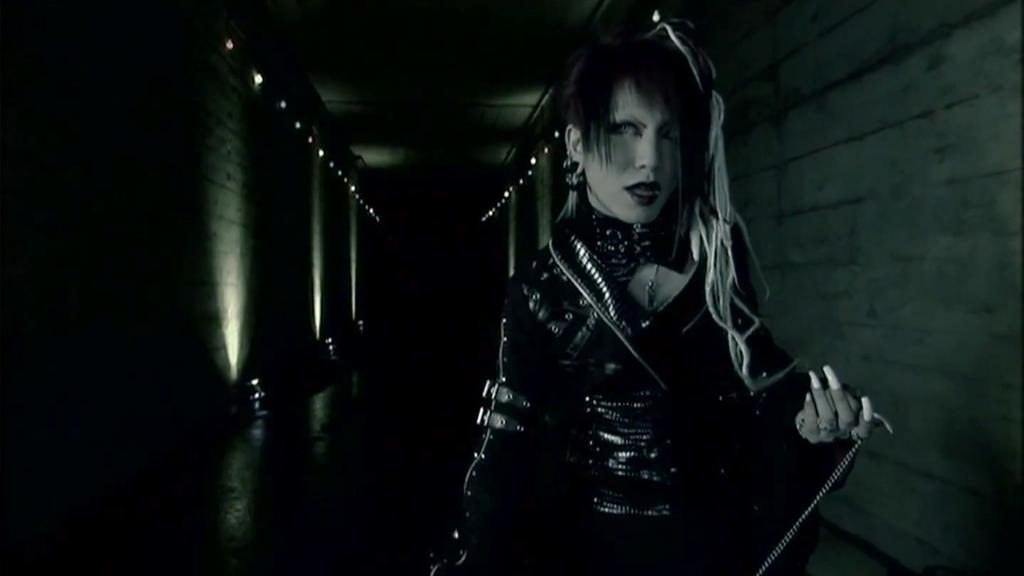Could you give a brief overview of what you see in this image? In this picture I see a woman in front who is standing and in the background I see the walls on which there are lights. I can also see that this image is in dark. 